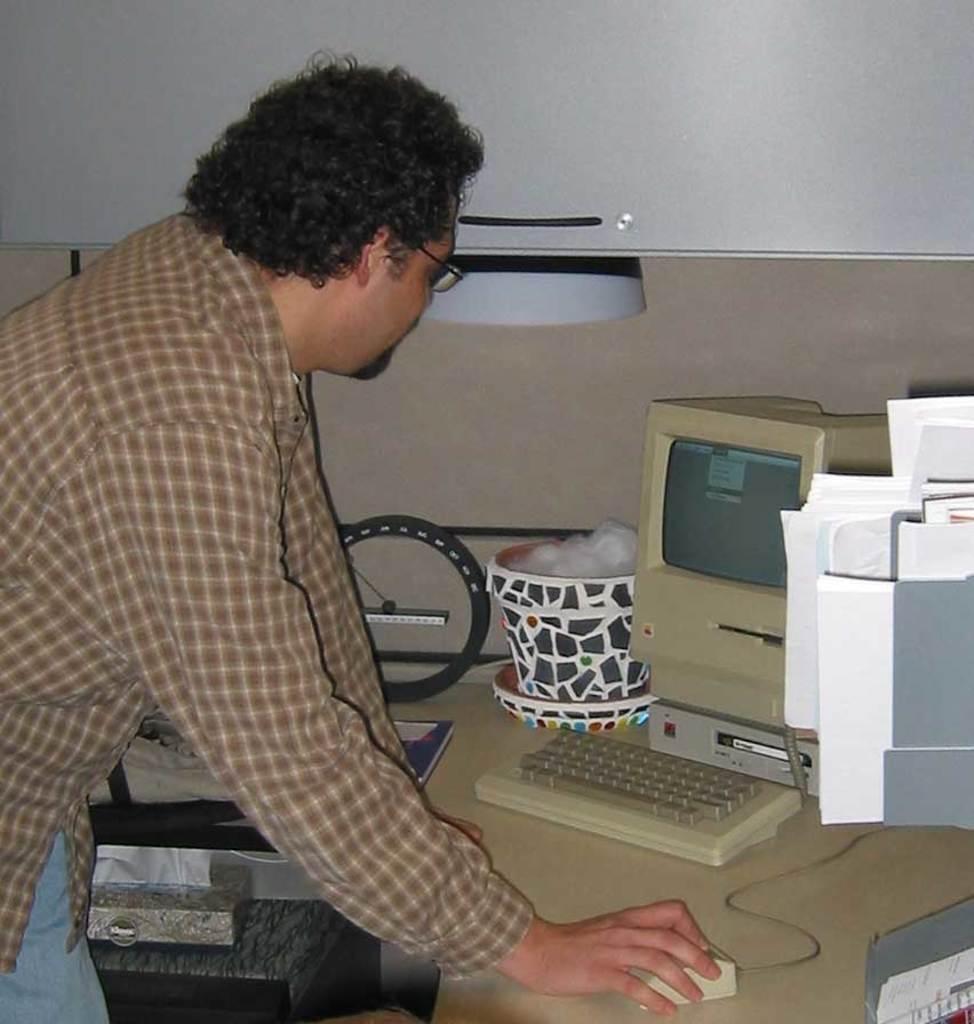In one or two sentences, can you explain what this image depicts? In this image there is a man standing and using the mouse which is on the table. There is a computer in front of him. On the table there are files,put,back,keyboard on it. 